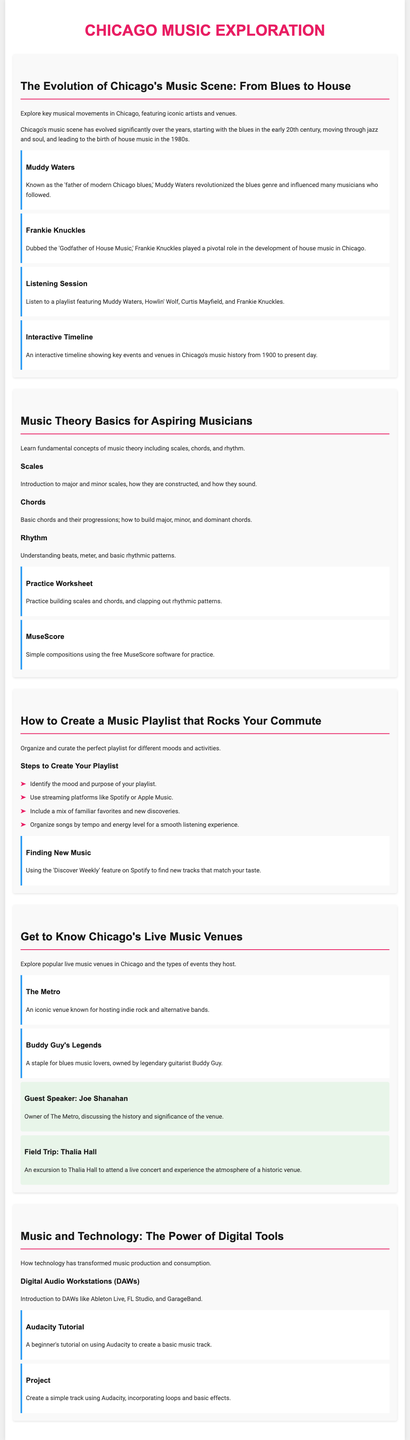What genre is Muddy Waters known for? Muddy Waters is known for being the 'father of modern Chicago blues,' indicating his impact on the blues genre.
Answer: Chicago blues Who is referred to as the 'Godfather of House Music'? Frankie Knuckles is specifically labeled as the 'Godfather of House Music,' highlighting his importance in that genre.
Answer: Frankie Knuckles What software is mentioned for creating compositions? The lesson plan details using MuseScore for simple compositions, which is a free music notation software.
Answer: MuseScore How many steps are suggested for creating a playlist? The document outlines four specific steps to create a playlist that caters to different moods and activities.
Answer: Four What type of music is Buddy Guy's Legends known for? Buddy Guy's Legends is described as a staple for blues music lovers, underlining the genre it is associated with.
Answer: Blues What is the title of the field trip mentioned? The field trip focuses on visiting Thalia Hall to attend a live concert and experience its historic venue atmosphere.
Answer: Thalia Hall Which technology tool is introduced for music production? Digital Audio Workstations (DAWs) such as Ableton Live and FL Studio are discussed in the lesson plan as important tools for music production.
Answer: DAWs What concept is covered under the Music Theory Basics module? The module covers fundamental concepts such as scales, chords, and rhythm, essential for beginners in music theory.
Answer: Scales, chords, rhythm What event is linked to Joe Shanahan? Joe Shanahan, the owner of The Metro, is a guest speaker discussing the history and significance of the venue.
Answer: The Metro 